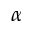Convert formula to latex. <formula><loc_0><loc_0><loc_500><loc_500>\alpha</formula> 